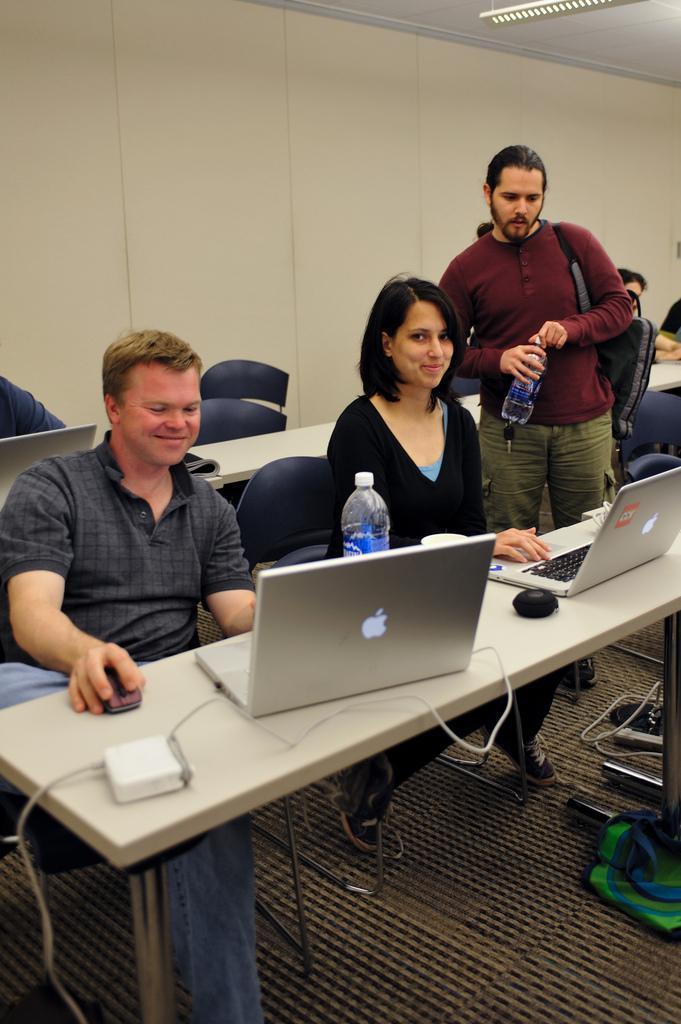How many people are using silver laptops?
Give a very brief answer. 2. 